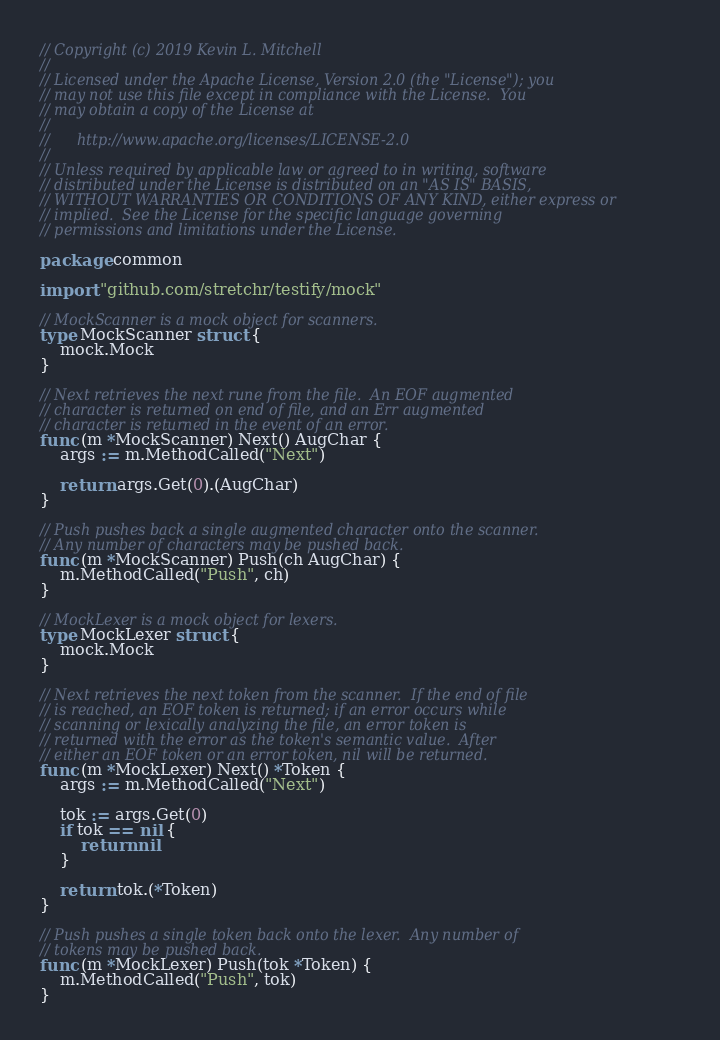<code> <loc_0><loc_0><loc_500><loc_500><_Go_>// Copyright (c) 2019 Kevin L. Mitchell
//
// Licensed under the Apache License, Version 2.0 (the "License"); you
// may not use this file except in compliance with the License.  You
// may obtain a copy of the License at
//
//      http://www.apache.org/licenses/LICENSE-2.0
//
// Unless required by applicable law or agreed to in writing, software
// distributed under the License is distributed on an "AS IS" BASIS,
// WITHOUT WARRANTIES OR CONDITIONS OF ANY KIND, either express or
// implied.  See the License for the specific language governing
// permissions and limitations under the License.

package common

import "github.com/stretchr/testify/mock"

// MockScanner is a mock object for scanners.
type MockScanner struct {
	mock.Mock
}

// Next retrieves the next rune from the file.  An EOF augmented
// character is returned on end of file, and an Err augmented
// character is returned in the event of an error.
func (m *MockScanner) Next() AugChar {
	args := m.MethodCalled("Next")

	return args.Get(0).(AugChar)
}

// Push pushes back a single augmented character onto the scanner.
// Any number of characters may be pushed back.
func (m *MockScanner) Push(ch AugChar) {
	m.MethodCalled("Push", ch)
}

// MockLexer is a mock object for lexers.
type MockLexer struct {
	mock.Mock
}

// Next retrieves the next token from the scanner.  If the end of file
// is reached, an EOF token is returned; if an error occurs while
// scanning or lexically analyzing the file, an error token is
// returned with the error as the token's semantic value.  After
// either an EOF token or an error token, nil will be returned.
func (m *MockLexer) Next() *Token {
	args := m.MethodCalled("Next")

	tok := args.Get(0)
	if tok == nil {
		return nil
	}

	return tok.(*Token)
}

// Push pushes a single token back onto the lexer.  Any number of
// tokens may be pushed back.
func (m *MockLexer) Push(tok *Token) {
	m.MethodCalled("Push", tok)
}
</code> 